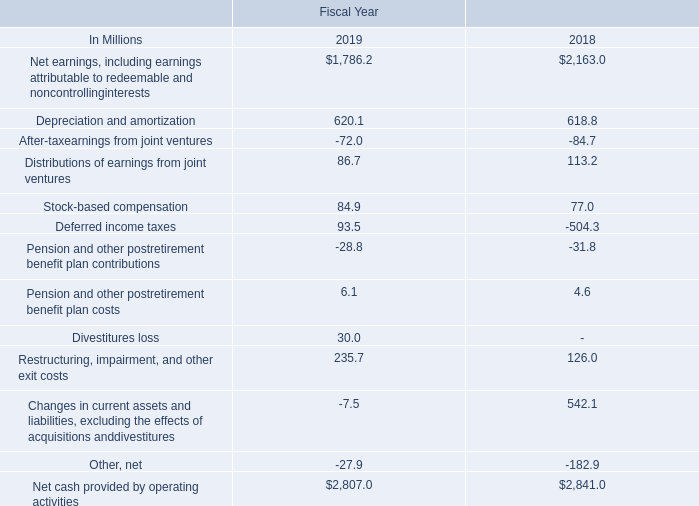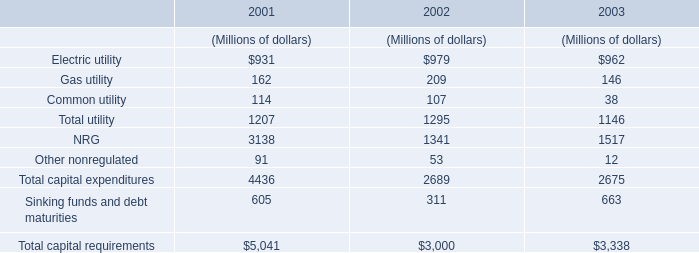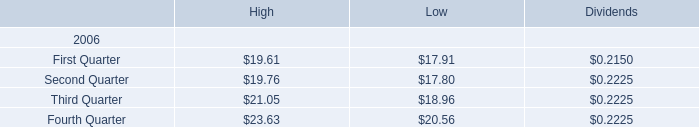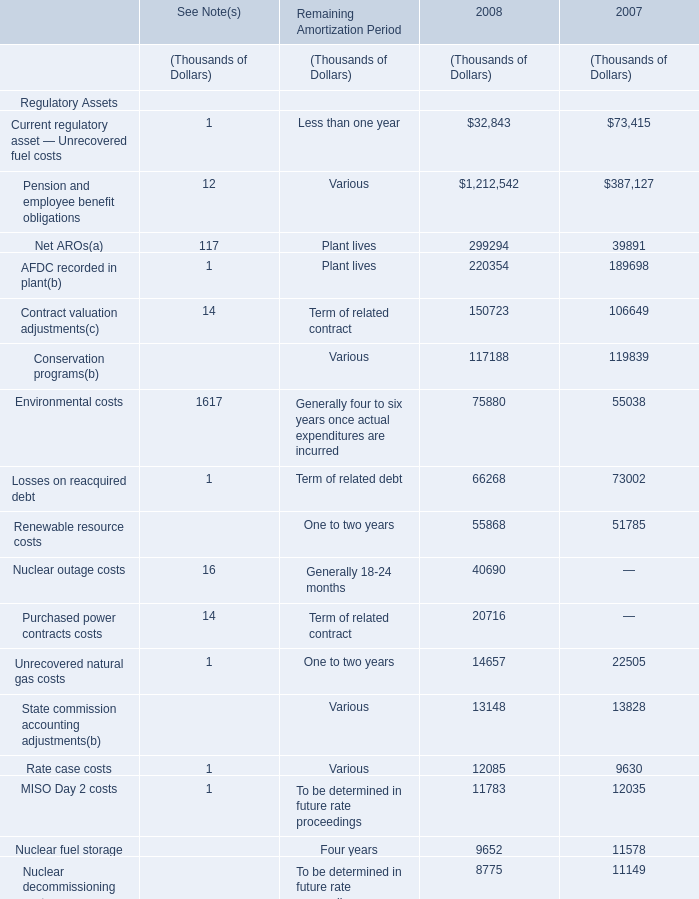during fiscal 2019 , what was the percent of the change in the cash provided by operations 
Computations: ((2807 - 2841) / 2841)
Answer: -0.01197. 